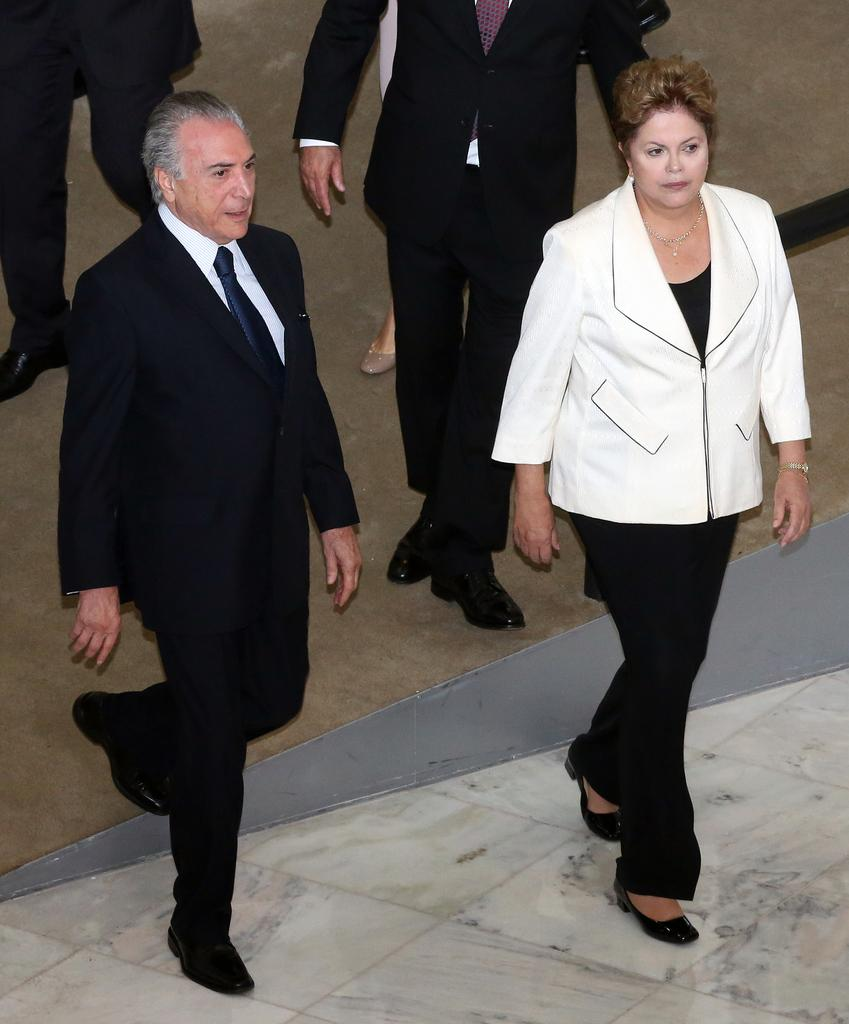How many persons can be seen in the image? There are two persons in the front. Can you describe the persons in the image? One of the persons is a man, and the other person is a woman. What is the woman wearing in the image? The woman is wearing a black dress. What is the man wearing in the image? The man is wearing a white coat. What type of boat can be seen in the image? There is no boat present in the image. What color is the silver object in the image? There is no silver object present in the image. 